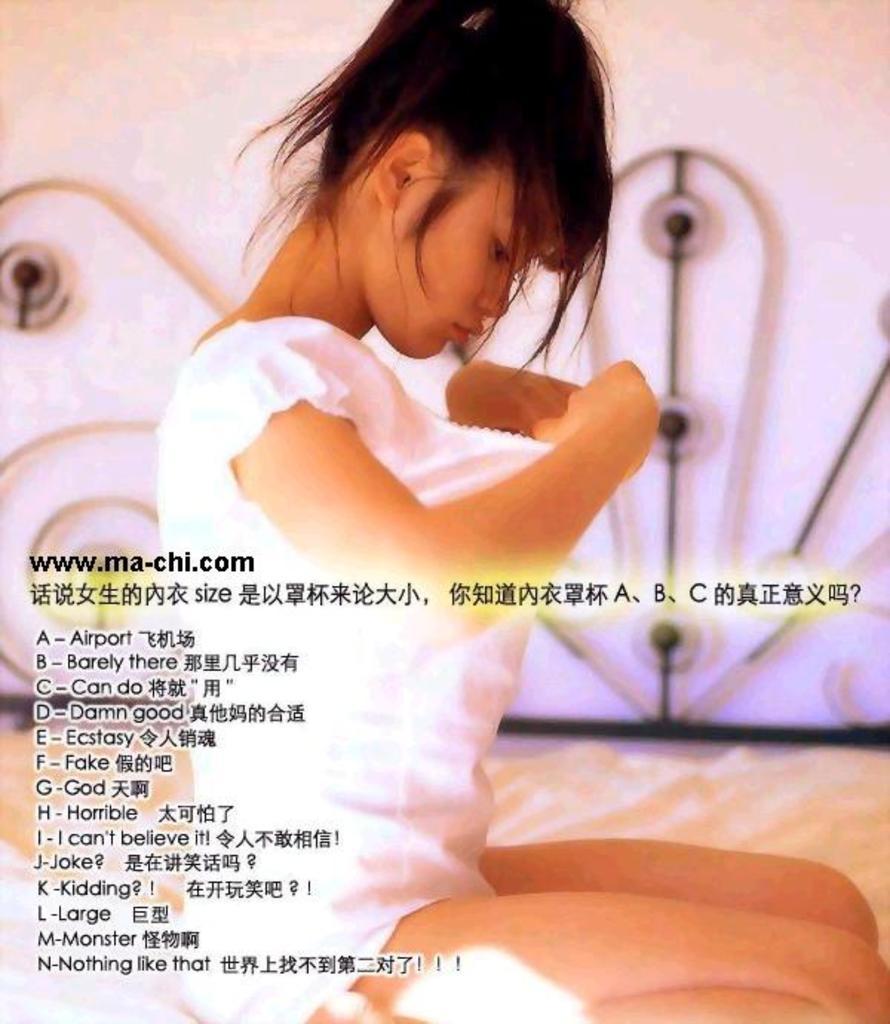Describe this image in one or two sentences. Here in this picture we can see a woman in a white colored dress sitting on a bed present over there. 